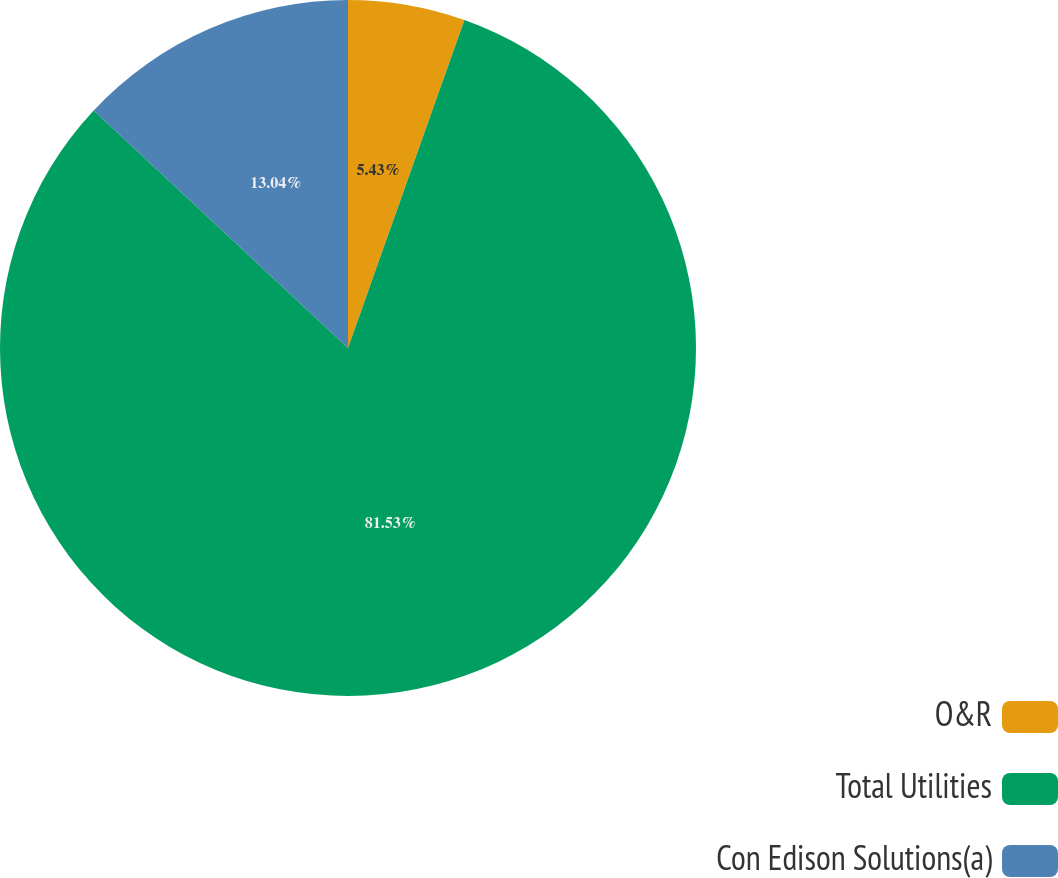<chart> <loc_0><loc_0><loc_500><loc_500><pie_chart><fcel>O&R<fcel>Total Utilities<fcel>Con Edison Solutions(a)<nl><fcel>5.43%<fcel>81.52%<fcel>13.04%<nl></chart> 